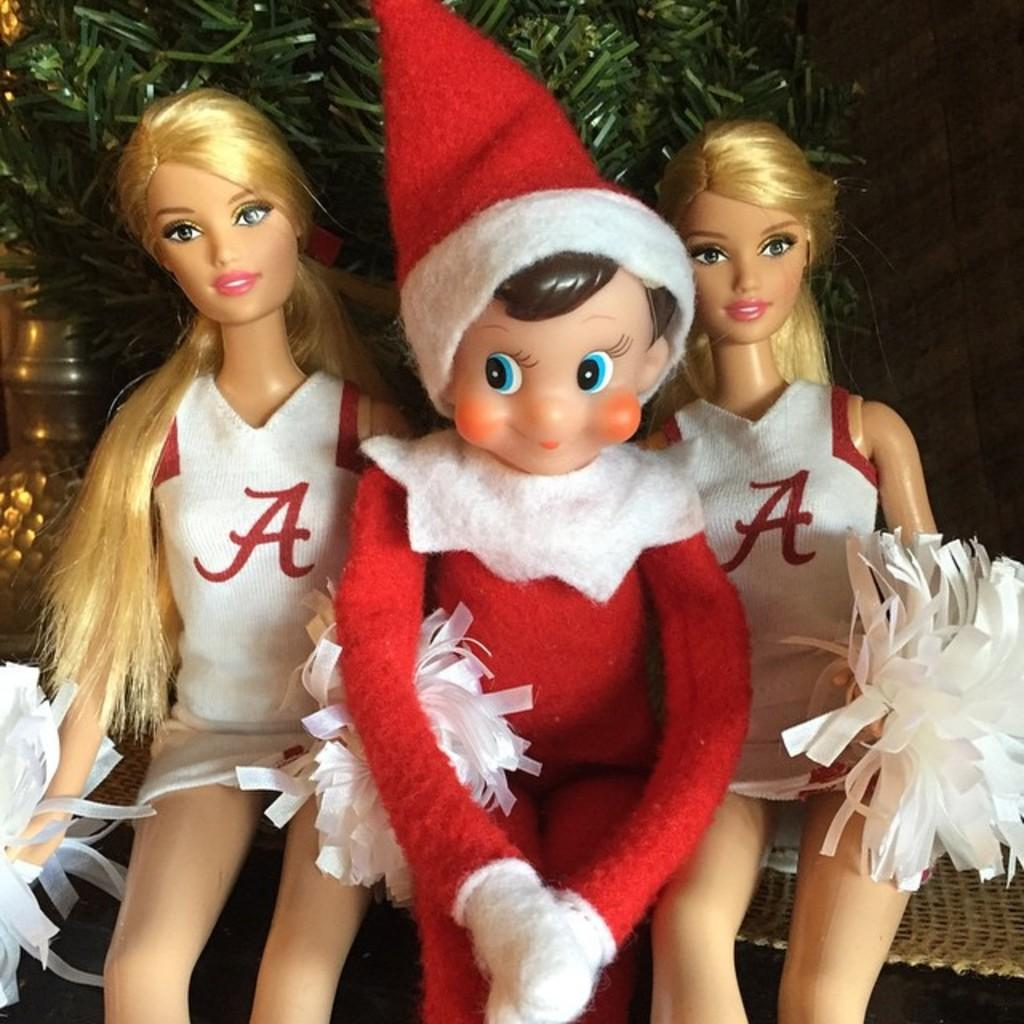What type of objects are in the image? There are dolls in the image. What else can be seen with the dolls? There are ribbons in the image. Can you describe the background of the image? There is a green color object in the background of the image, along with a few unspecified things. What type of process is being carried out by the dolls in the image? There is no process being carried out by the dolls in the image; they are simply objects in the scene. 